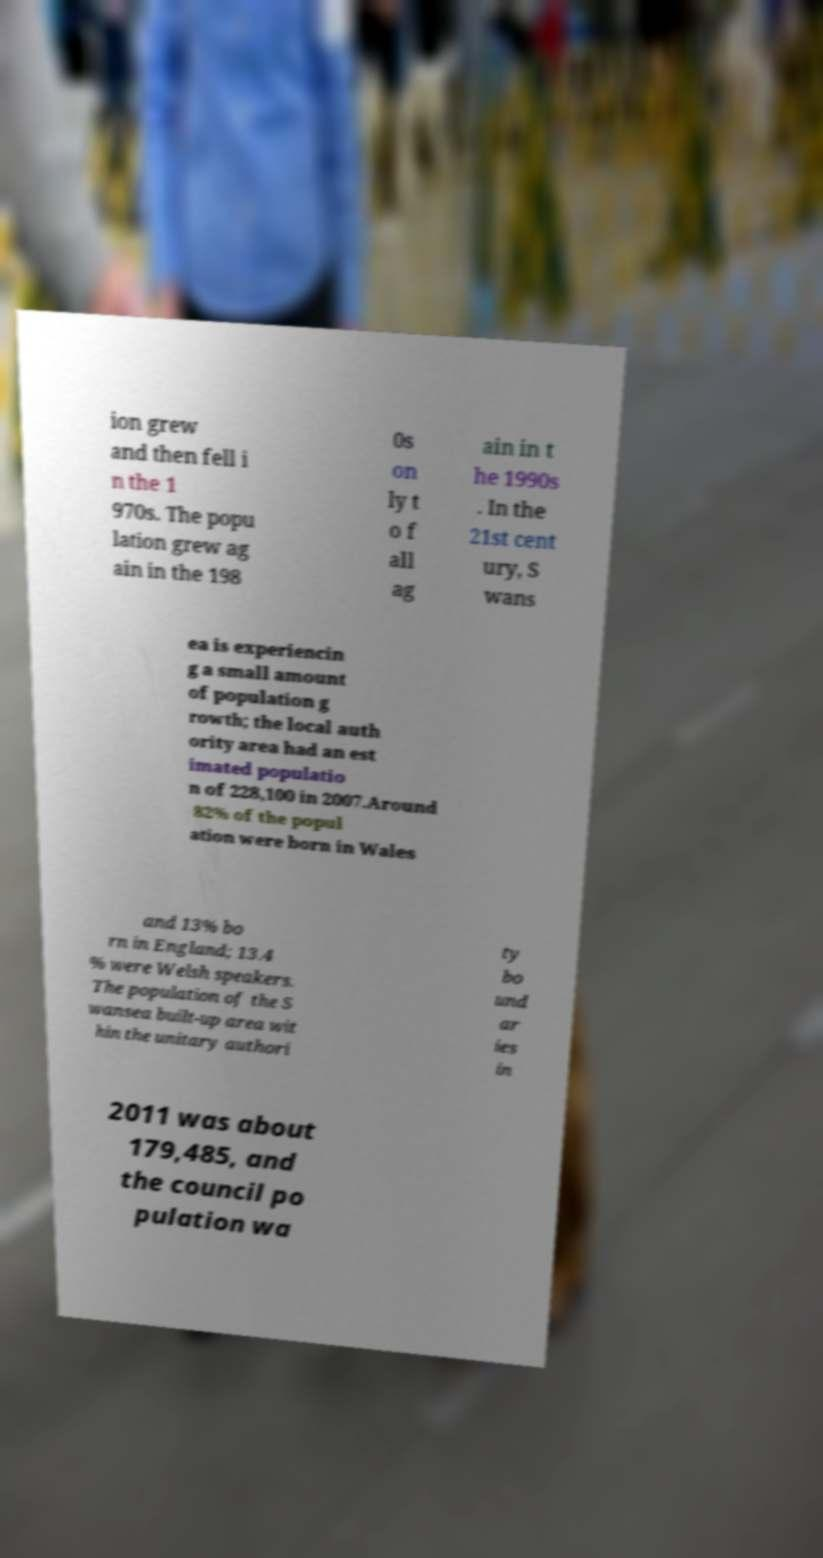For documentation purposes, I need the text within this image transcribed. Could you provide that? ion grew and then fell i n the 1 970s. The popu lation grew ag ain in the 198 0s on ly t o f all ag ain in t he 1990s . In the 21st cent ury, S wans ea is experiencin g a small amount of population g rowth; the local auth ority area had an est imated populatio n of 228,100 in 2007.Around 82% of the popul ation were born in Wales and 13% bo rn in England; 13.4 % were Welsh speakers. The population of the S wansea built-up area wit hin the unitary authori ty bo und ar ies in 2011 was about 179,485, and the council po pulation wa 